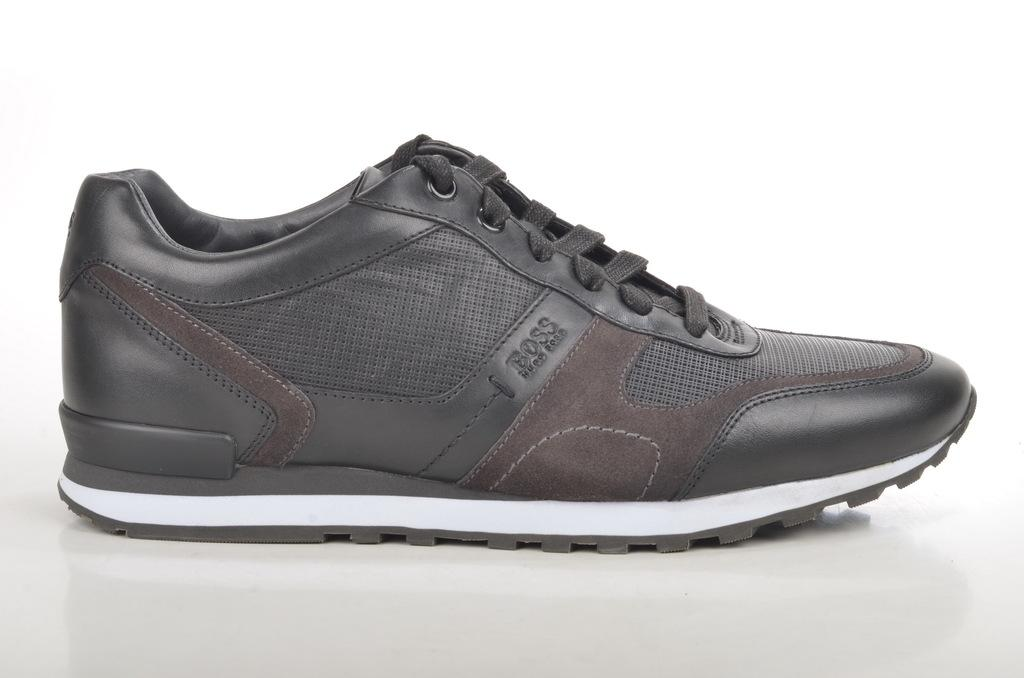What object is the main focus of the image? There is a shoe in the image. Where is the shoe located? The shoe is on a platform. What type of prose can be seen written on the shoe in the image? There is no prose written on the shoe in the image. 